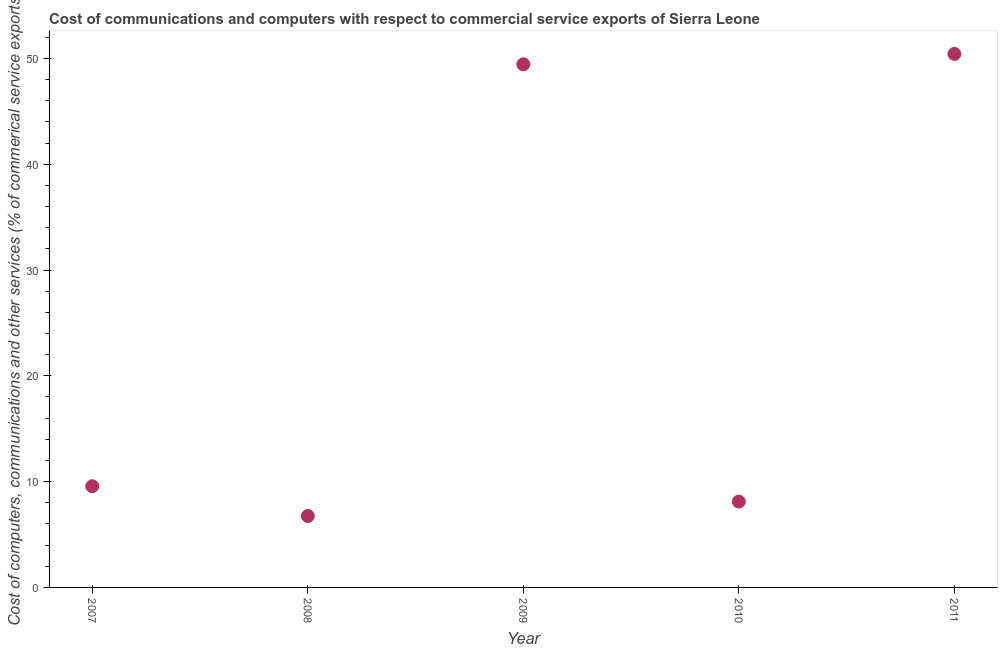What is the  computer and other services in 2008?
Keep it short and to the point. 6.75. Across all years, what is the maximum  computer and other services?
Your answer should be compact. 50.42. Across all years, what is the minimum cost of communications?
Provide a short and direct response. 6.75. In which year was the  computer and other services maximum?
Offer a very short reply. 2011. What is the sum of the cost of communications?
Offer a very short reply. 124.29. What is the difference between the  computer and other services in 2008 and 2011?
Provide a short and direct response. -43.67. What is the average  computer and other services per year?
Your answer should be very brief. 24.86. What is the median cost of communications?
Offer a very short reply. 9.56. Do a majority of the years between 2011 and 2008 (inclusive) have  computer and other services greater than 2 %?
Make the answer very short. Yes. What is the ratio of the cost of communications in 2009 to that in 2010?
Make the answer very short. 6.09. Is the  computer and other services in 2008 less than that in 2011?
Provide a short and direct response. Yes. What is the difference between the highest and the second highest  computer and other services?
Provide a succinct answer. 0.98. Is the sum of the cost of communications in 2007 and 2009 greater than the maximum cost of communications across all years?
Your response must be concise. Yes. What is the difference between the highest and the lowest  computer and other services?
Offer a very short reply. 43.67. Does the cost of communications monotonically increase over the years?
Your response must be concise. No. Does the graph contain grids?
Your answer should be very brief. No. What is the title of the graph?
Provide a succinct answer. Cost of communications and computers with respect to commercial service exports of Sierra Leone. What is the label or title of the Y-axis?
Your answer should be compact. Cost of computers, communications and other services (% of commerical service exports). What is the Cost of computers, communications and other services (% of commerical service exports) in 2007?
Ensure brevity in your answer.  9.56. What is the Cost of computers, communications and other services (% of commerical service exports) in 2008?
Make the answer very short. 6.75. What is the Cost of computers, communications and other services (% of commerical service exports) in 2009?
Keep it short and to the point. 49.44. What is the Cost of computers, communications and other services (% of commerical service exports) in 2010?
Provide a short and direct response. 8.11. What is the Cost of computers, communications and other services (% of commerical service exports) in 2011?
Provide a short and direct response. 50.42. What is the difference between the Cost of computers, communications and other services (% of commerical service exports) in 2007 and 2008?
Offer a very short reply. 2.81. What is the difference between the Cost of computers, communications and other services (% of commerical service exports) in 2007 and 2009?
Give a very brief answer. -39.88. What is the difference between the Cost of computers, communications and other services (% of commerical service exports) in 2007 and 2010?
Your response must be concise. 1.45. What is the difference between the Cost of computers, communications and other services (% of commerical service exports) in 2007 and 2011?
Ensure brevity in your answer.  -40.86. What is the difference between the Cost of computers, communications and other services (% of commerical service exports) in 2008 and 2009?
Your response must be concise. -42.69. What is the difference between the Cost of computers, communications and other services (% of commerical service exports) in 2008 and 2010?
Keep it short and to the point. -1.36. What is the difference between the Cost of computers, communications and other services (% of commerical service exports) in 2008 and 2011?
Make the answer very short. -43.67. What is the difference between the Cost of computers, communications and other services (% of commerical service exports) in 2009 and 2010?
Offer a terse response. 41.33. What is the difference between the Cost of computers, communications and other services (% of commerical service exports) in 2009 and 2011?
Give a very brief answer. -0.98. What is the difference between the Cost of computers, communications and other services (% of commerical service exports) in 2010 and 2011?
Ensure brevity in your answer.  -42.31. What is the ratio of the Cost of computers, communications and other services (% of commerical service exports) in 2007 to that in 2008?
Offer a terse response. 1.42. What is the ratio of the Cost of computers, communications and other services (% of commerical service exports) in 2007 to that in 2009?
Give a very brief answer. 0.19. What is the ratio of the Cost of computers, communications and other services (% of commerical service exports) in 2007 to that in 2010?
Your answer should be very brief. 1.18. What is the ratio of the Cost of computers, communications and other services (% of commerical service exports) in 2007 to that in 2011?
Offer a terse response. 0.19. What is the ratio of the Cost of computers, communications and other services (% of commerical service exports) in 2008 to that in 2009?
Provide a short and direct response. 0.14. What is the ratio of the Cost of computers, communications and other services (% of commerical service exports) in 2008 to that in 2010?
Ensure brevity in your answer.  0.83. What is the ratio of the Cost of computers, communications and other services (% of commerical service exports) in 2008 to that in 2011?
Offer a very short reply. 0.13. What is the ratio of the Cost of computers, communications and other services (% of commerical service exports) in 2009 to that in 2010?
Your answer should be compact. 6.09. What is the ratio of the Cost of computers, communications and other services (% of commerical service exports) in 2010 to that in 2011?
Your answer should be compact. 0.16. 